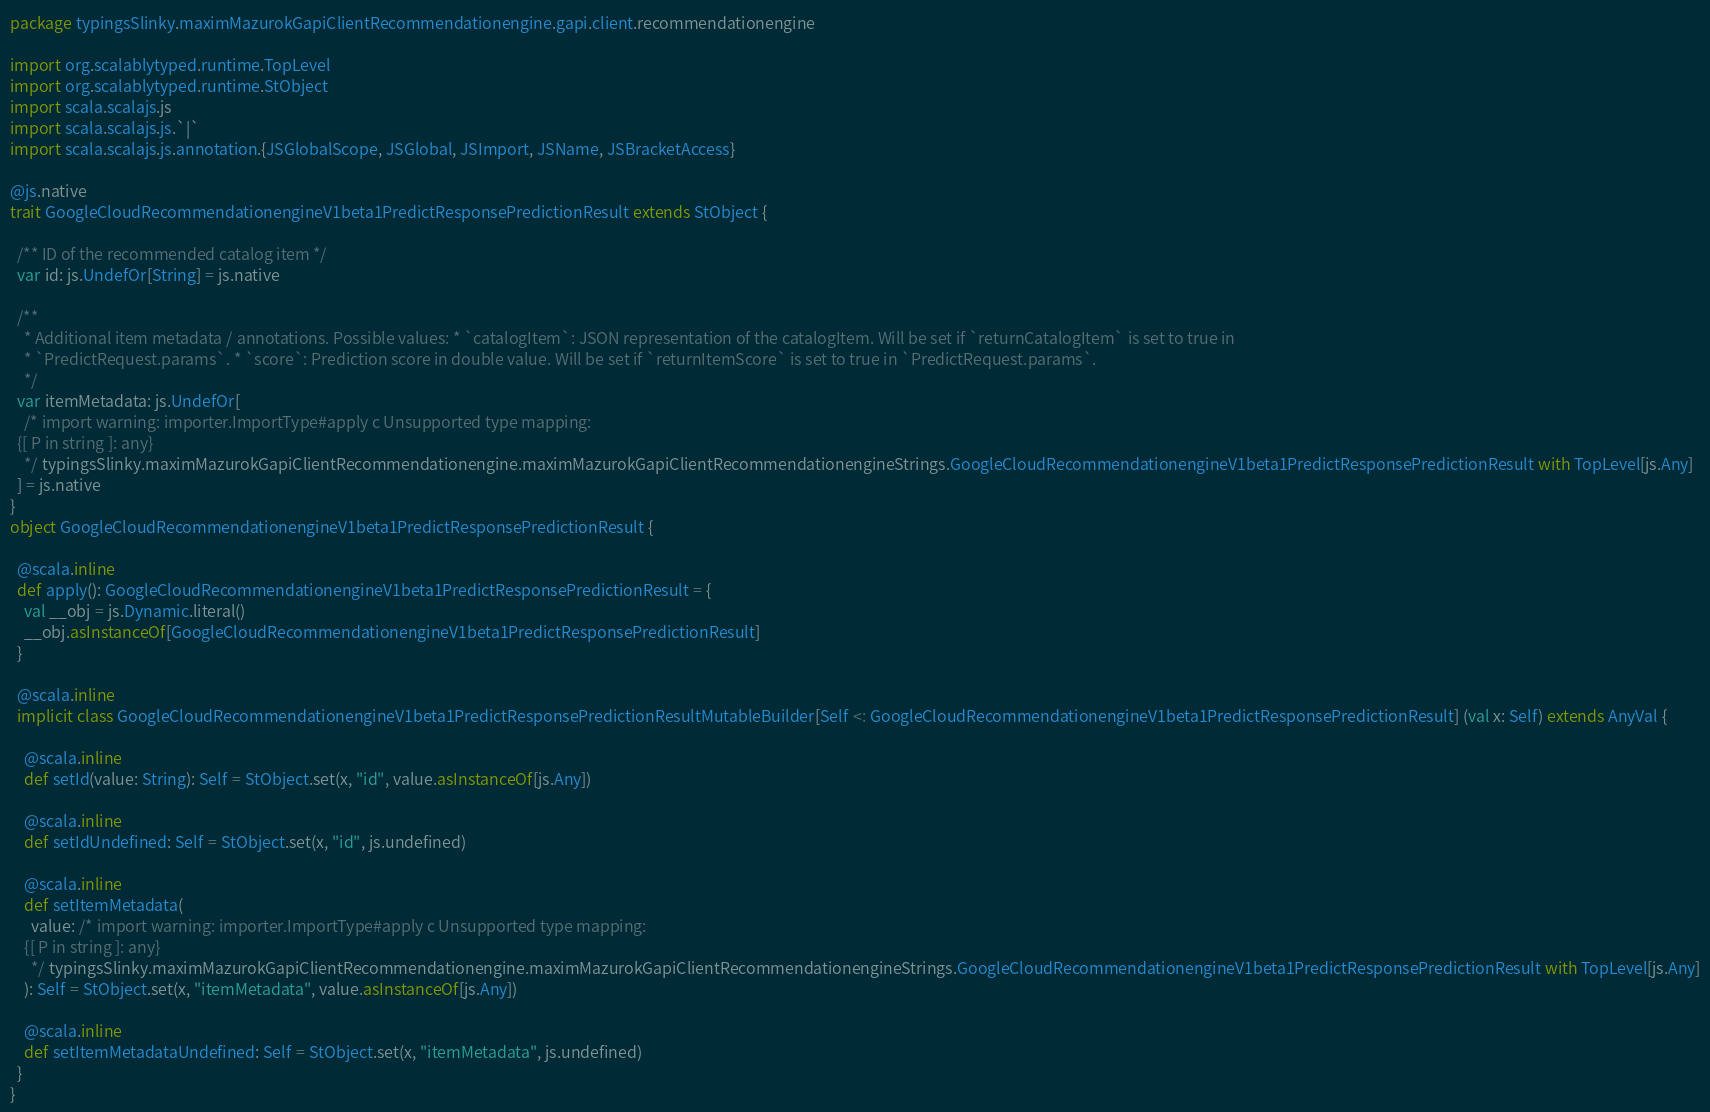Convert code to text. <code><loc_0><loc_0><loc_500><loc_500><_Scala_>package typingsSlinky.maximMazurokGapiClientRecommendationengine.gapi.client.recommendationengine

import org.scalablytyped.runtime.TopLevel
import org.scalablytyped.runtime.StObject
import scala.scalajs.js
import scala.scalajs.js.`|`
import scala.scalajs.js.annotation.{JSGlobalScope, JSGlobal, JSImport, JSName, JSBracketAccess}

@js.native
trait GoogleCloudRecommendationengineV1beta1PredictResponsePredictionResult extends StObject {
  
  /** ID of the recommended catalog item */
  var id: js.UndefOr[String] = js.native
  
  /**
    * Additional item metadata / annotations. Possible values: * `catalogItem`: JSON representation of the catalogItem. Will be set if `returnCatalogItem` is set to true in
    * `PredictRequest.params`. * `score`: Prediction score in double value. Will be set if `returnItemScore` is set to true in `PredictRequest.params`.
    */
  var itemMetadata: js.UndefOr[
    /* import warning: importer.ImportType#apply c Unsupported type mapping: 
  {[ P in string ]: any}
    */ typingsSlinky.maximMazurokGapiClientRecommendationengine.maximMazurokGapiClientRecommendationengineStrings.GoogleCloudRecommendationengineV1beta1PredictResponsePredictionResult with TopLevel[js.Any]
  ] = js.native
}
object GoogleCloudRecommendationengineV1beta1PredictResponsePredictionResult {
  
  @scala.inline
  def apply(): GoogleCloudRecommendationengineV1beta1PredictResponsePredictionResult = {
    val __obj = js.Dynamic.literal()
    __obj.asInstanceOf[GoogleCloudRecommendationengineV1beta1PredictResponsePredictionResult]
  }
  
  @scala.inline
  implicit class GoogleCloudRecommendationengineV1beta1PredictResponsePredictionResultMutableBuilder[Self <: GoogleCloudRecommendationengineV1beta1PredictResponsePredictionResult] (val x: Self) extends AnyVal {
    
    @scala.inline
    def setId(value: String): Self = StObject.set(x, "id", value.asInstanceOf[js.Any])
    
    @scala.inline
    def setIdUndefined: Self = StObject.set(x, "id", js.undefined)
    
    @scala.inline
    def setItemMetadata(
      value: /* import warning: importer.ImportType#apply c Unsupported type mapping: 
    {[ P in string ]: any}
      */ typingsSlinky.maximMazurokGapiClientRecommendationengine.maximMazurokGapiClientRecommendationengineStrings.GoogleCloudRecommendationengineV1beta1PredictResponsePredictionResult with TopLevel[js.Any]
    ): Self = StObject.set(x, "itemMetadata", value.asInstanceOf[js.Any])
    
    @scala.inline
    def setItemMetadataUndefined: Self = StObject.set(x, "itemMetadata", js.undefined)
  }
}
</code> 